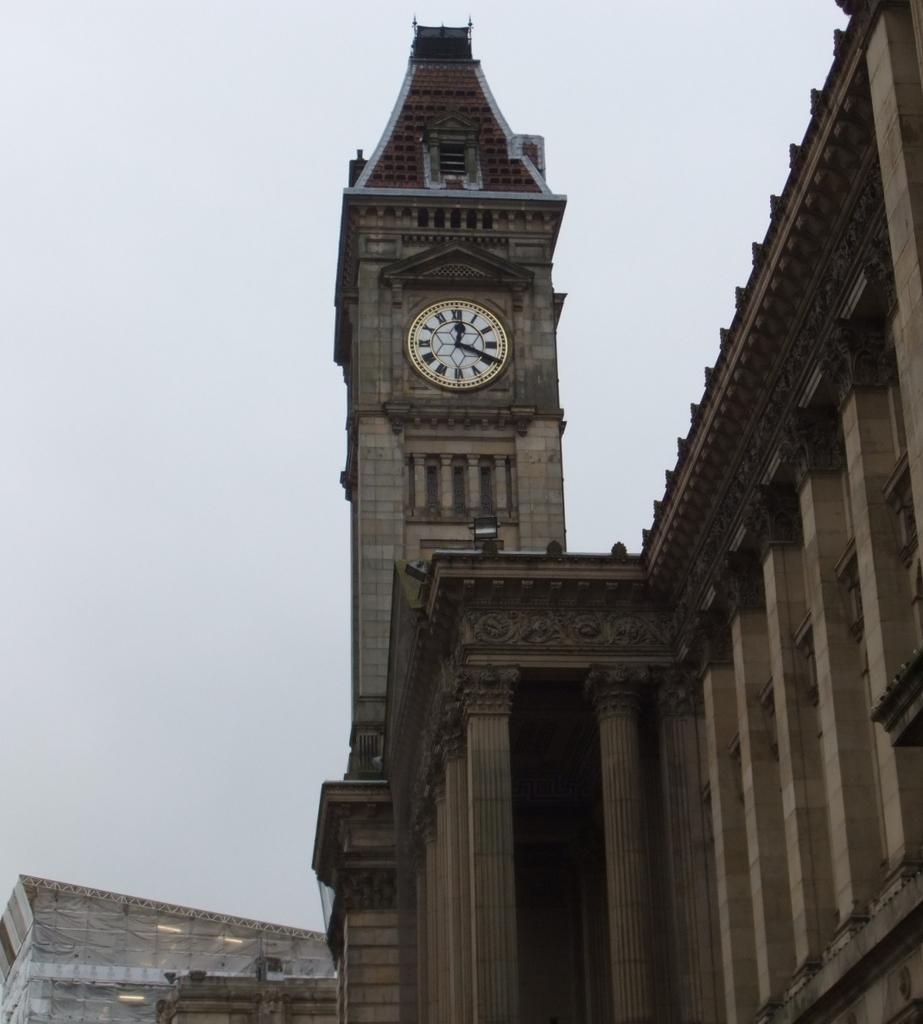Can you describe this image briefly? In this image we can see the buildings, on the building we can see a clock, there are some pillars and also we can see the sky. 